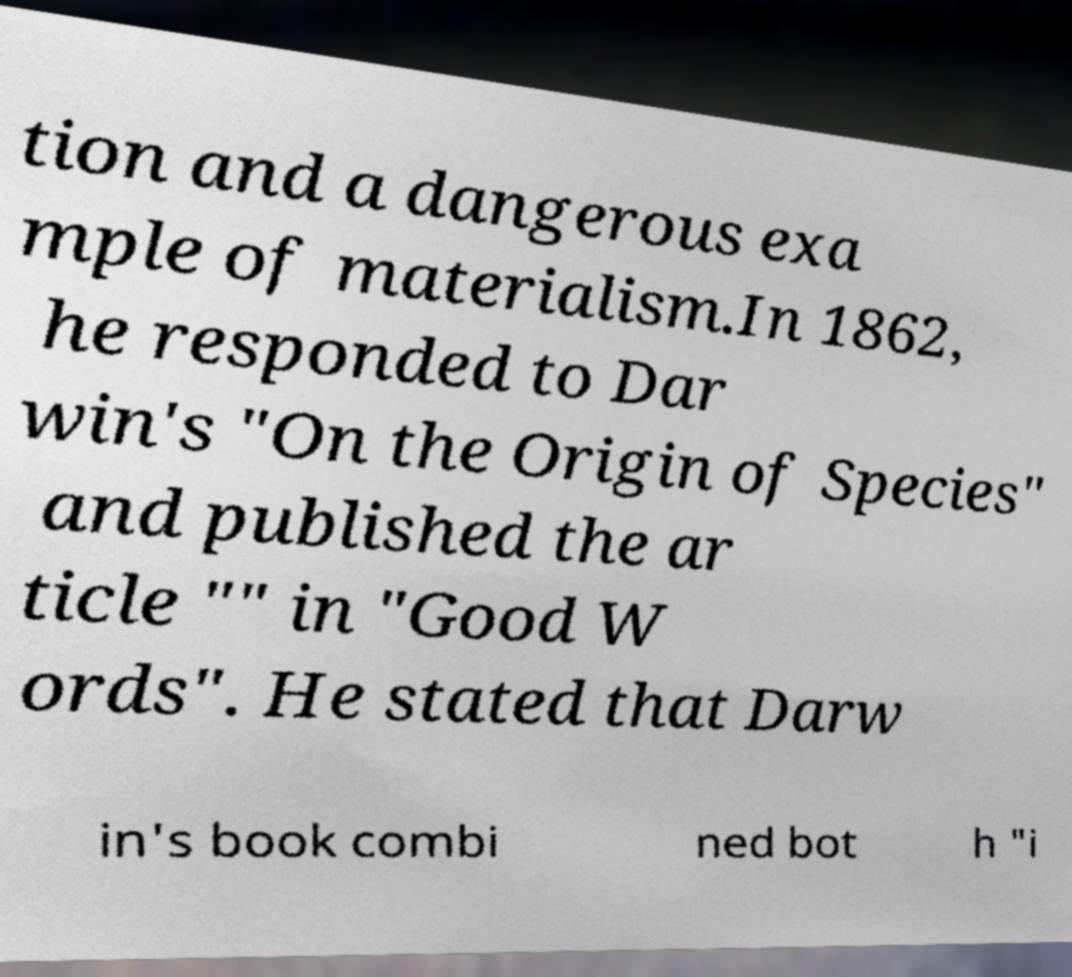What messages or text are displayed in this image? I need them in a readable, typed format. tion and a dangerous exa mple of materialism.In 1862, he responded to Dar win's "On the Origin of Species" and published the ar ticle "" in "Good W ords". He stated that Darw in's book combi ned bot h "i 